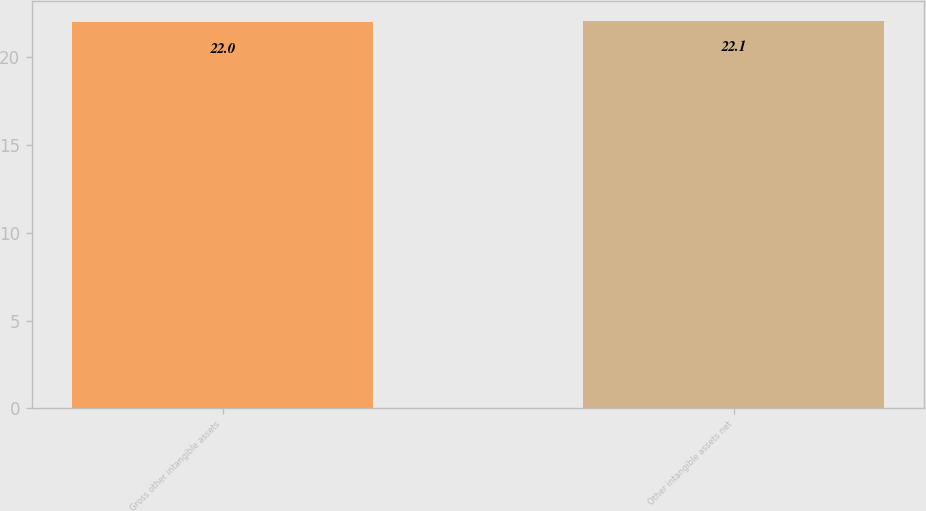Convert chart to OTSL. <chart><loc_0><loc_0><loc_500><loc_500><bar_chart><fcel>Gross other intangible assets<fcel>Other intangible assets net<nl><fcel>22<fcel>22.1<nl></chart> 